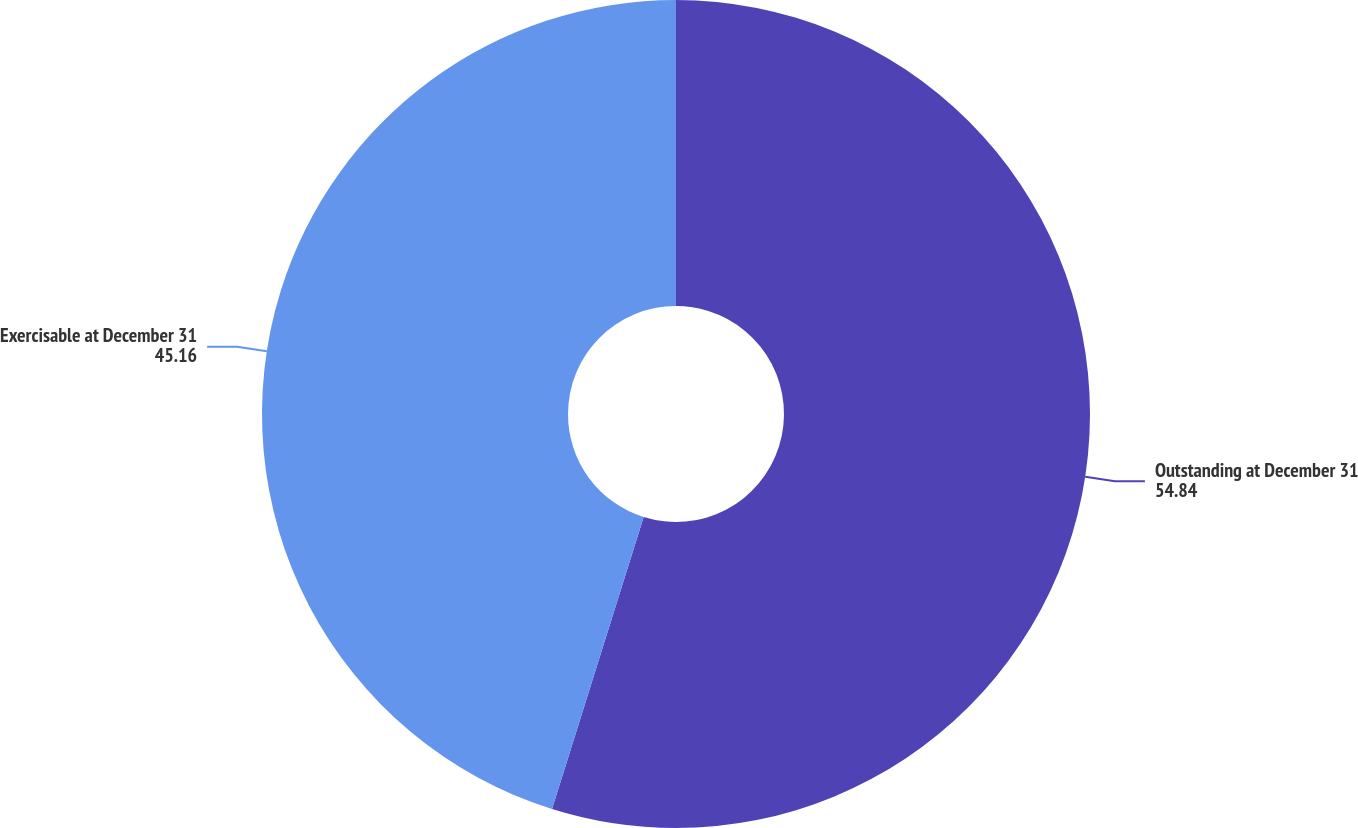Convert chart. <chart><loc_0><loc_0><loc_500><loc_500><pie_chart><fcel>Outstanding at December 31<fcel>Exercisable at December 31<nl><fcel>54.84%<fcel>45.16%<nl></chart> 